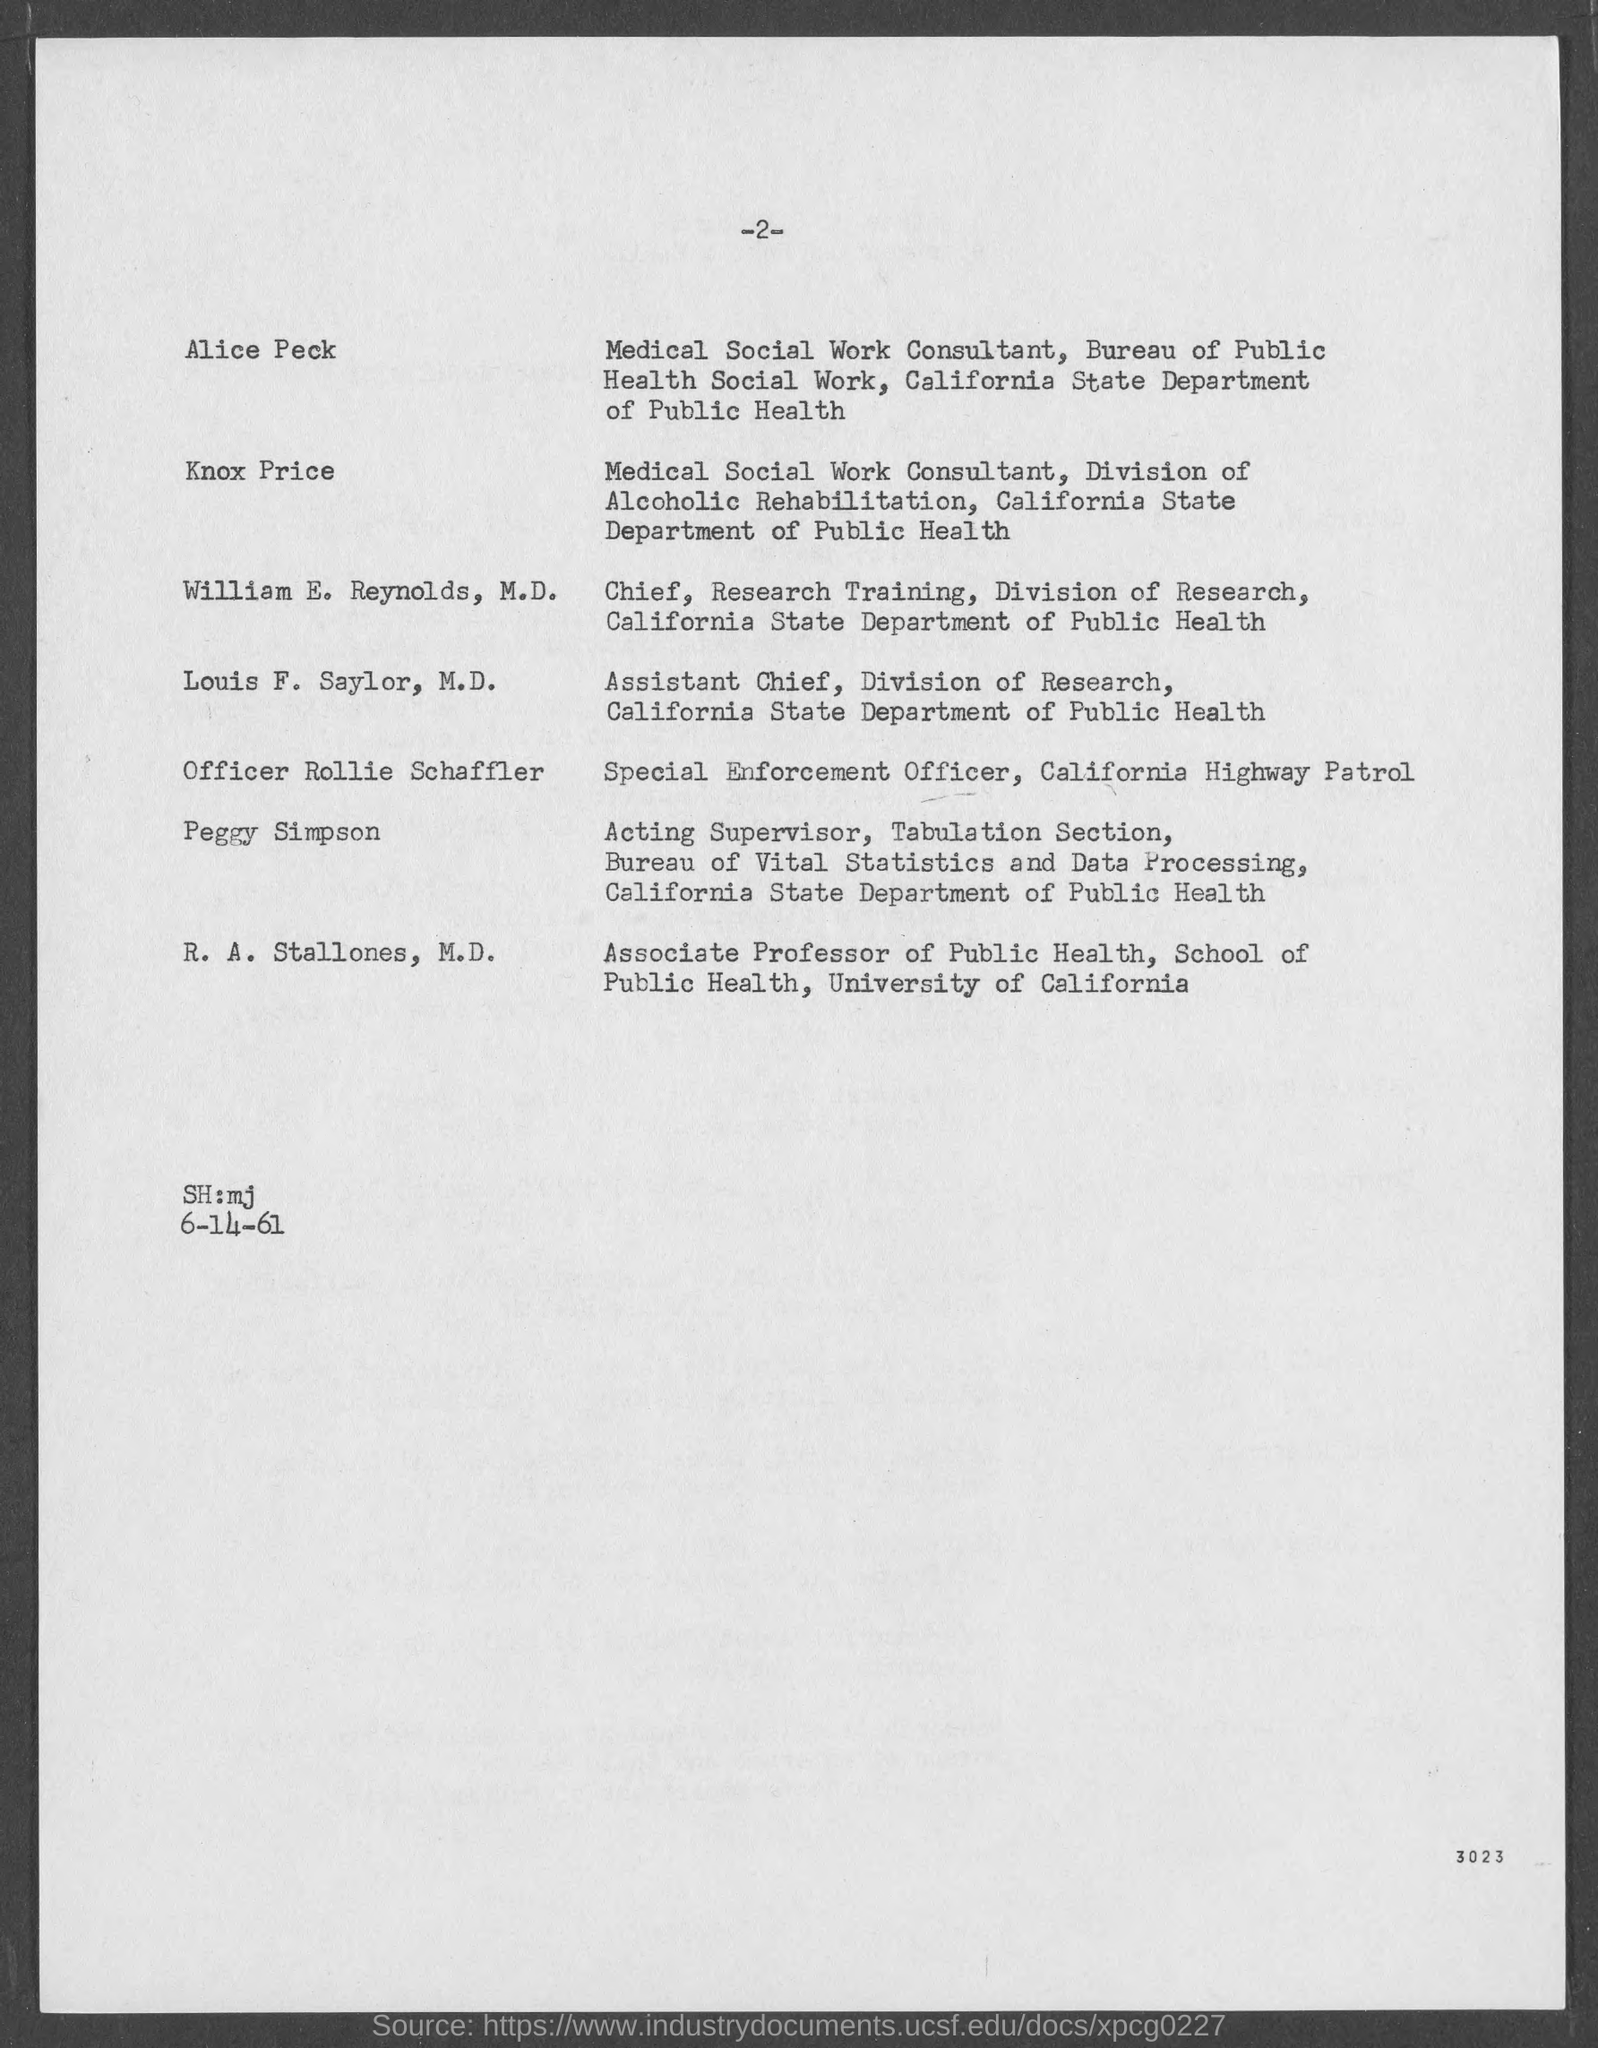Mention the page number given at top of the page?
Ensure brevity in your answer.  2. Provide the name of "Special Enforcement Officer, California Highway Patrol"?
Your response must be concise. Officer Rollie Schaffler. Provide the name of "Medical Social Work consultant, Bureau of Public Health Social Work,California State Department of Public Health"?
Keep it short and to the point. Alice Peck. Provide the name of "Medical Social Work consultant, Division of Alcoholic Rehabilitation, California State Department of Public Health"?
Provide a short and direct response. KNOX PRICE. Provide the name of "Chief, Research Training, Division of Research,California State Department of Public Health"?
Your answer should be very brief. WILLIAM E. REYNOLDS, M.D. Provide the name of "Assistant Chief, Division of Research,California State Department of Public Health"?
Offer a terse response. LOUIS F. SAYLOR, M.D. Provide the name of "Associate Professor of Public Health, School of Public Health,University of California"?
Your answer should be compact. R.A. STALLONES. Mention the number given at right bottom corner of the page?
Offer a terse response. 3023. "R.A. Stallones" is working as "Associate Professor of Public Health" in which University?
Your answer should be compact. University of California. Provide the date given?
Keep it short and to the point. 6-14-61. 